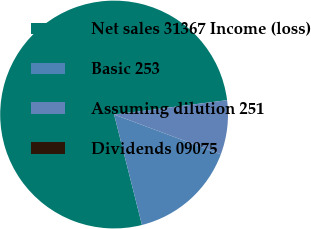Convert chart. <chart><loc_0><loc_0><loc_500><loc_500><pie_chart><fcel>Net sales 31367 Income (loss)<fcel>Basic 253<fcel>Assuming dilution 251<fcel>Dividends 09075<nl><fcel>76.92%<fcel>15.39%<fcel>7.69%<fcel>0.0%<nl></chart> 